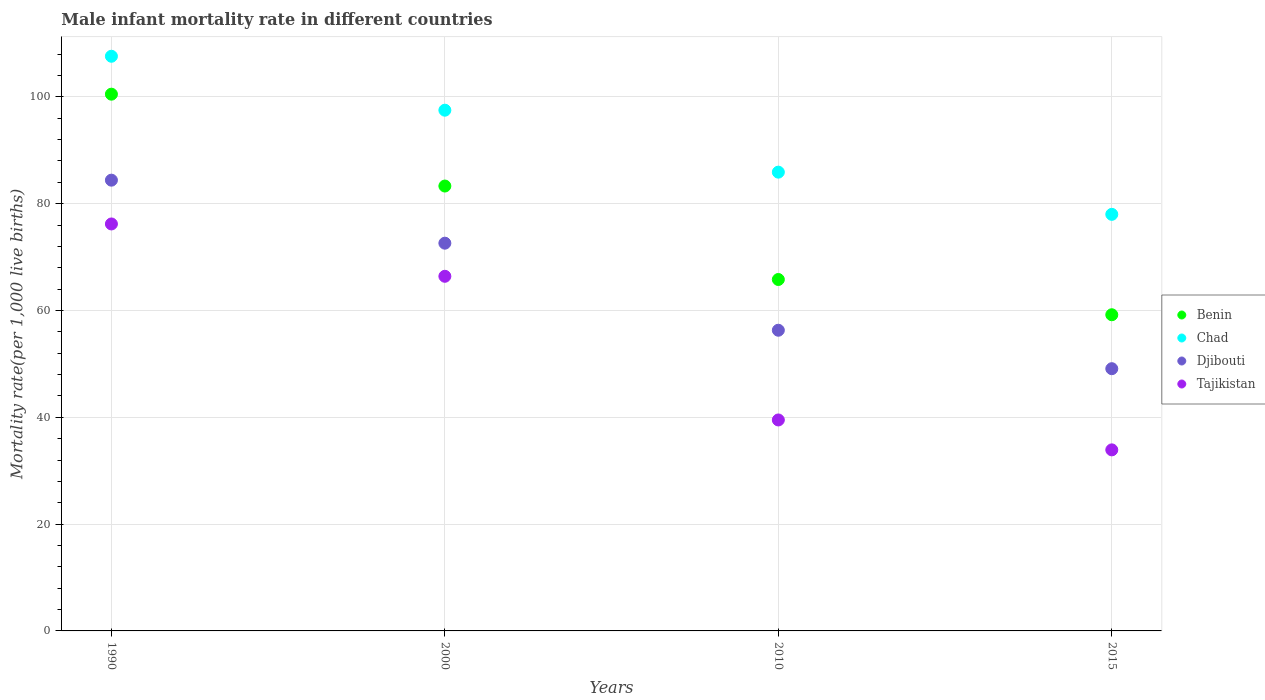Is the number of dotlines equal to the number of legend labels?
Your answer should be compact. Yes. What is the male infant mortality rate in Chad in 2000?
Your response must be concise. 97.5. Across all years, what is the maximum male infant mortality rate in Benin?
Offer a very short reply. 100.5. Across all years, what is the minimum male infant mortality rate in Benin?
Give a very brief answer. 59.2. In which year was the male infant mortality rate in Chad maximum?
Keep it short and to the point. 1990. In which year was the male infant mortality rate in Benin minimum?
Your answer should be very brief. 2015. What is the total male infant mortality rate in Tajikistan in the graph?
Give a very brief answer. 216. What is the difference between the male infant mortality rate in Djibouti in 1990 and that in 2015?
Provide a short and direct response. 35.3. What is the difference between the male infant mortality rate in Chad in 2000 and the male infant mortality rate in Tajikistan in 1990?
Your answer should be very brief. 21.3. What is the average male infant mortality rate in Djibouti per year?
Give a very brief answer. 65.6. In the year 2010, what is the difference between the male infant mortality rate in Chad and male infant mortality rate in Tajikistan?
Offer a terse response. 46.4. In how many years, is the male infant mortality rate in Chad greater than 40?
Give a very brief answer. 4. What is the ratio of the male infant mortality rate in Djibouti in 1990 to that in 2000?
Keep it short and to the point. 1.16. What is the difference between the highest and the second highest male infant mortality rate in Benin?
Provide a short and direct response. 17.2. What is the difference between the highest and the lowest male infant mortality rate in Chad?
Provide a succinct answer. 29.6. Is it the case that in every year, the sum of the male infant mortality rate in Chad and male infant mortality rate in Djibouti  is greater than the male infant mortality rate in Benin?
Your answer should be very brief. Yes. Does the male infant mortality rate in Chad monotonically increase over the years?
Your response must be concise. No. Is the male infant mortality rate in Tajikistan strictly greater than the male infant mortality rate in Benin over the years?
Provide a short and direct response. No. How many dotlines are there?
Offer a very short reply. 4. How many years are there in the graph?
Ensure brevity in your answer.  4. Are the values on the major ticks of Y-axis written in scientific E-notation?
Ensure brevity in your answer.  No. Does the graph contain any zero values?
Offer a very short reply. No. Does the graph contain grids?
Make the answer very short. Yes. How many legend labels are there?
Keep it short and to the point. 4. How are the legend labels stacked?
Give a very brief answer. Vertical. What is the title of the graph?
Offer a terse response. Male infant mortality rate in different countries. What is the label or title of the X-axis?
Provide a short and direct response. Years. What is the label or title of the Y-axis?
Your answer should be very brief. Mortality rate(per 1,0 live births). What is the Mortality rate(per 1,000 live births) of Benin in 1990?
Make the answer very short. 100.5. What is the Mortality rate(per 1,000 live births) of Chad in 1990?
Offer a terse response. 107.6. What is the Mortality rate(per 1,000 live births) of Djibouti in 1990?
Your answer should be very brief. 84.4. What is the Mortality rate(per 1,000 live births) of Tajikistan in 1990?
Offer a terse response. 76.2. What is the Mortality rate(per 1,000 live births) in Benin in 2000?
Ensure brevity in your answer.  83.3. What is the Mortality rate(per 1,000 live births) in Chad in 2000?
Offer a very short reply. 97.5. What is the Mortality rate(per 1,000 live births) of Djibouti in 2000?
Make the answer very short. 72.6. What is the Mortality rate(per 1,000 live births) in Tajikistan in 2000?
Offer a very short reply. 66.4. What is the Mortality rate(per 1,000 live births) in Benin in 2010?
Make the answer very short. 65.8. What is the Mortality rate(per 1,000 live births) of Chad in 2010?
Offer a terse response. 85.9. What is the Mortality rate(per 1,000 live births) in Djibouti in 2010?
Your answer should be very brief. 56.3. What is the Mortality rate(per 1,000 live births) in Tajikistan in 2010?
Ensure brevity in your answer.  39.5. What is the Mortality rate(per 1,000 live births) of Benin in 2015?
Offer a very short reply. 59.2. What is the Mortality rate(per 1,000 live births) of Chad in 2015?
Offer a very short reply. 78. What is the Mortality rate(per 1,000 live births) in Djibouti in 2015?
Your answer should be very brief. 49.1. What is the Mortality rate(per 1,000 live births) of Tajikistan in 2015?
Keep it short and to the point. 33.9. Across all years, what is the maximum Mortality rate(per 1,000 live births) of Benin?
Offer a terse response. 100.5. Across all years, what is the maximum Mortality rate(per 1,000 live births) in Chad?
Ensure brevity in your answer.  107.6. Across all years, what is the maximum Mortality rate(per 1,000 live births) of Djibouti?
Make the answer very short. 84.4. Across all years, what is the maximum Mortality rate(per 1,000 live births) of Tajikistan?
Keep it short and to the point. 76.2. Across all years, what is the minimum Mortality rate(per 1,000 live births) in Benin?
Provide a succinct answer. 59.2. Across all years, what is the minimum Mortality rate(per 1,000 live births) of Djibouti?
Offer a very short reply. 49.1. Across all years, what is the minimum Mortality rate(per 1,000 live births) of Tajikistan?
Your answer should be compact. 33.9. What is the total Mortality rate(per 1,000 live births) in Benin in the graph?
Your response must be concise. 308.8. What is the total Mortality rate(per 1,000 live births) of Chad in the graph?
Provide a short and direct response. 369. What is the total Mortality rate(per 1,000 live births) of Djibouti in the graph?
Your answer should be very brief. 262.4. What is the total Mortality rate(per 1,000 live births) in Tajikistan in the graph?
Make the answer very short. 216. What is the difference between the Mortality rate(per 1,000 live births) of Benin in 1990 and that in 2000?
Provide a short and direct response. 17.2. What is the difference between the Mortality rate(per 1,000 live births) of Djibouti in 1990 and that in 2000?
Your answer should be compact. 11.8. What is the difference between the Mortality rate(per 1,000 live births) in Benin in 1990 and that in 2010?
Make the answer very short. 34.7. What is the difference between the Mortality rate(per 1,000 live births) in Chad in 1990 and that in 2010?
Your response must be concise. 21.7. What is the difference between the Mortality rate(per 1,000 live births) of Djibouti in 1990 and that in 2010?
Give a very brief answer. 28.1. What is the difference between the Mortality rate(per 1,000 live births) of Tajikistan in 1990 and that in 2010?
Your response must be concise. 36.7. What is the difference between the Mortality rate(per 1,000 live births) of Benin in 1990 and that in 2015?
Give a very brief answer. 41.3. What is the difference between the Mortality rate(per 1,000 live births) in Chad in 1990 and that in 2015?
Your response must be concise. 29.6. What is the difference between the Mortality rate(per 1,000 live births) of Djibouti in 1990 and that in 2015?
Keep it short and to the point. 35.3. What is the difference between the Mortality rate(per 1,000 live births) in Tajikistan in 1990 and that in 2015?
Make the answer very short. 42.3. What is the difference between the Mortality rate(per 1,000 live births) of Benin in 2000 and that in 2010?
Your answer should be very brief. 17.5. What is the difference between the Mortality rate(per 1,000 live births) in Chad in 2000 and that in 2010?
Your answer should be compact. 11.6. What is the difference between the Mortality rate(per 1,000 live births) of Tajikistan in 2000 and that in 2010?
Make the answer very short. 26.9. What is the difference between the Mortality rate(per 1,000 live births) in Benin in 2000 and that in 2015?
Offer a terse response. 24.1. What is the difference between the Mortality rate(per 1,000 live births) in Chad in 2000 and that in 2015?
Keep it short and to the point. 19.5. What is the difference between the Mortality rate(per 1,000 live births) in Tajikistan in 2000 and that in 2015?
Offer a very short reply. 32.5. What is the difference between the Mortality rate(per 1,000 live births) of Djibouti in 2010 and that in 2015?
Provide a short and direct response. 7.2. What is the difference between the Mortality rate(per 1,000 live births) of Tajikistan in 2010 and that in 2015?
Your response must be concise. 5.6. What is the difference between the Mortality rate(per 1,000 live births) in Benin in 1990 and the Mortality rate(per 1,000 live births) in Djibouti in 2000?
Provide a short and direct response. 27.9. What is the difference between the Mortality rate(per 1,000 live births) in Benin in 1990 and the Mortality rate(per 1,000 live births) in Tajikistan in 2000?
Offer a terse response. 34.1. What is the difference between the Mortality rate(per 1,000 live births) of Chad in 1990 and the Mortality rate(per 1,000 live births) of Djibouti in 2000?
Ensure brevity in your answer.  35. What is the difference between the Mortality rate(per 1,000 live births) in Chad in 1990 and the Mortality rate(per 1,000 live births) in Tajikistan in 2000?
Keep it short and to the point. 41.2. What is the difference between the Mortality rate(per 1,000 live births) of Benin in 1990 and the Mortality rate(per 1,000 live births) of Djibouti in 2010?
Ensure brevity in your answer.  44.2. What is the difference between the Mortality rate(per 1,000 live births) of Chad in 1990 and the Mortality rate(per 1,000 live births) of Djibouti in 2010?
Offer a terse response. 51.3. What is the difference between the Mortality rate(per 1,000 live births) in Chad in 1990 and the Mortality rate(per 1,000 live births) in Tajikistan in 2010?
Offer a terse response. 68.1. What is the difference between the Mortality rate(per 1,000 live births) in Djibouti in 1990 and the Mortality rate(per 1,000 live births) in Tajikistan in 2010?
Make the answer very short. 44.9. What is the difference between the Mortality rate(per 1,000 live births) in Benin in 1990 and the Mortality rate(per 1,000 live births) in Chad in 2015?
Your answer should be very brief. 22.5. What is the difference between the Mortality rate(per 1,000 live births) of Benin in 1990 and the Mortality rate(per 1,000 live births) of Djibouti in 2015?
Your answer should be very brief. 51.4. What is the difference between the Mortality rate(per 1,000 live births) in Benin in 1990 and the Mortality rate(per 1,000 live births) in Tajikistan in 2015?
Your answer should be compact. 66.6. What is the difference between the Mortality rate(per 1,000 live births) of Chad in 1990 and the Mortality rate(per 1,000 live births) of Djibouti in 2015?
Keep it short and to the point. 58.5. What is the difference between the Mortality rate(per 1,000 live births) in Chad in 1990 and the Mortality rate(per 1,000 live births) in Tajikistan in 2015?
Give a very brief answer. 73.7. What is the difference between the Mortality rate(per 1,000 live births) in Djibouti in 1990 and the Mortality rate(per 1,000 live births) in Tajikistan in 2015?
Your answer should be compact. 50.5. What is the difference between the Mortality rate(per 1,000 live births) in Benin in 2000 and the Mortality rate(per 1,000 live births) in Chad in 2010?
Offer a terse response. -2.6. What is the difference between the Mortality rate(per 1,000 live births) of Benin in 2000 and the Mortality rate(per 1,000 live births) of Djibouti in 2010?
Your answer should be compact. 27. What is the difference between the Mortality rate(per 1,000 live births) in Benin in 2000 and the Mortality rate(per 1,000 live births) in Tajikistan in 2010?
Your response must be concise. 43.8. What is the difference between the Mortality rate(per 1,000 live births) of Chad in 2000 and the Mortality rate(per 1,000 live births) of Djibouti in 2010?
Provide a short and direct response. 41.2. What is the difference between the Mortality rate(per 1,000 live births) of Chad in 2000 and the Mortality rate(per 1,000 live births) of Tajikistan in 2010?
Your answer should be compact. 58. What is the difference between the Mortality rate(per 1,000 live births) in Djibouti in 2000 and the Mortality rate(per 1,000 live births) in Tajikistan in 2010?
Make the answer very short. 33.1. What is the difference between the Mortality rate(per 1,000 live births) of Benin in 2000 and the Mortality rate(per 1,000 live births) of Chad in 2015?
Ensure brevity in your answer.  5.3. What is the difference between the Mortality rate(per 1,000 live births) of Benin in 2000 and the Mortality rate(per 1,000 live births) of Djibouti in 2015?
Provide a succinct answer. 34.2. What is the difference between the Mortality rate(per 1,000 live births) in Benin in 2000 and the Mortality rate(per 1,000 live births) in Tajikistan in 2015?
Your answer should be compact. 49.4. What is the difference between the Mortality rate(per 1,000 live births) of Chad in 2000 and the Mortality rate(per 1,000 live births) of Djibouti in 2015?
Provide a short and direct response. 48.4. What is the difference between the Mortality rate(per 1,000 live births) of Chad in 2000 and the Mortality rate(per 1,000 live births) of Tajikistan in 2015?
Provide a short and direct response. 63.6. What is the difference between the Mortality rate(per 1,000 live births) of Djibouti in 2000 and the Mortality rate(per 1,000 live births) of Tajikistan in 2015?
Provide a succinct answer. 38.7. What is the difference between the Mortality rate(per 1,000 live births) of Benin in 2010 and the Mortality rate(per 1,000 live births) of Djibouti in 2015?
Give a very brief answer. 16.7. What is the difference between the Mortality rate(per 1,000 live births) of Benin in 2010 and the Mortality rate(per 1,000 live births) of Tajikistan in 2015?
Provide a succinct answer. 31.9. What is the difference between the Mortality rate(per 1,000 live births) in Chad in 2010 and the Mortality rate(per 1,000 live births) in Djibouti in 2015?
Provide a succinct answer. 36.8. What is the difference between the Mortality rate(per 1,000 live births) in Djibouti in 2010 and the Mortality rate(per 1,000 live births) in Tajikistan in 2015?
Provide a succinct answer. 22.4. What is the average Mortality rate(per 1,000 live births) of Benin per year?
Your answer should be very brief. 77.2. What is the average Mortality rate(per 1,000 live births) in Chad per year?
Your answer should be very brief. 92.25. What is the average Mortality rate(per 1,000 live births) of Djibouti per year?
Offer a very short reply. 65.6. What is the average Mortality rate(per 1,000 live births) in Tajikistan per year?
Offer a very short reply. 54. In the year 1990, what is the difference between the Mortality rate(per 1,000 live births) of Benin and Mortality rate(per 1,000 live births) of Tajikistan?
Ensure brevity in your answer.  24.3. In the year 1990, what is the difference between the Mortality rate(per 1,000 live births) in Chad and Mortality rate(per 1,000 live births) in Djibouti?
Offer a terse response. 23.2. In the year 1990, what is the difference between the Mortality rate(per 1,000 live births) in Chad and Mortality rate(per 1,000 live births) in Tajikistan?
Give a very brief answer. 31.4. In the year 2000, what is the difference between the Mortality rate(per 1,000 live births) in Benin and Mortality rate(per 1,000 live births) in Djibouti?
Ensure brevity in your answer.  10.7. In the year 2000, what is the difference between the Mortality rate(per 1,000 live births) in Chad and Mortality rate(per 1,000 live births) in Djibouti?
Keep it short and to the point. 24.9. In the year 2000, what is the difference between the Mortality rate(per 1,000 live births) of Chad and Mortality rate(per 1,000 live births) of Tajikistan?
Your answer should be very brief. 31.1. In the year 2000, what is the difference between the Mortality rate(per 1,000 live births) in Djibouti and Mortality rate(per 1,000 live births) in Tajikistan?
Your answer should be very brief. 6.2. In the year 2010, what is the difference between the Mortality rate(per 1,000 live births) in Benin and Mortality rate(per 1,000 live births) in Chad?
Ensure brevity in your answer.  -20.1. In the year 2010, what is the difference between the Mortality rate(per 1,000 live births) in Benin and Mortality rate(per 1,000 live births) in Tajikistan?
Offer a very short reply. 26.3. In the year 2010, what is the difference between the Mortality rate(per 1,000 live births) in Chad and Mortality rate(per 1,000 live births) in Djibouti?
Your answer should be very brief. 29.6. In the year 2010, what is the difference between the Mortality rate(per 1,000 live births) in Chad and Mortality rate(per 1,000 live births) in Tajikistan?
Make the answer very short. 46.4. In the year 2010, what is the difference between the Mortality rate(per 1,000 live births) of Djibouti and Mortality rate(per 1,000 live births) of Tajikistan?
Provide a succinct answer. 16.8. In the year 2015, what is the difference between the Mortality rate(per 1,000 live births) in Benin and Mortality rate(per 1,000 live births) in Chad?
Your response must be concise. -18.8. In the year 2015, what is the difference between the Mortality rate(per 1,000 live births) of Benin and Mortality rate(per 1,000 live births) of Tajikistan?
Offer a terse response. 25.3. In the year 2015, what is the difference between the Mortality rate(per 1,000 live births) of Chad and Mortality rate(per 1,000 live births) of Djibouti?
Provide a succinct answer. 28.9. In the year 2015, what is the difference between the Mortality rate(per 1,000 live births) of Chad and Mortality rate(per 1,000 live births) of Tajikistan?
Offer a very short reply. 44.1. What is the ratio of the Mortality rate(per 1,000 live births) in Benin in 1990 to that in 2000?
Provide a short and direct response. 1.21. What is the ratio of the Mortality rate(per 1,000 live births) of Chad in 1990 to that in 2000?
Make the answer very short. 1.1. What is the ratio of the Mortality rate(per 1,000 live births) in Djibouti in 1990 to that in 2000?
Provide a short and direct response. 1.16. What is the ratio of the Mortality rate(per 1,000 live births) in Tajikistan in 1990 to that in 2000?
Make the answer very short. 1.15. What is the ratio of the Mortality rate(per 1,000 live births) in Benin in 1990 to that in 2010?
Your response must be concise. 1.53. What is the ratio of the Mortality rate(per 1,000 live births) in Chad in 1990 to that in 2010?
Make the answer very short. 1.25. What is the ratio of the Mortality rate(per 1,000 live births) of Djibouti in 1990 to that in 2010?
Your answer should be very brief. 1.5. What is the ratio of the Mortality rate(per 1,000 live births) in Tajikistan in 1990 to that in 2010?
Offer a terse response. 1.93. What is the ratio of the Mortality rate(per 1,000 live births) of Benin in 1990 to that in 2015?
Ensure brevity in your answer.  1.7. What is the ratio of the Mortality rate(per 1,000 live births) in Chad in 1990 to that in 2015?
Provide a short and direct response. 1.38. What is the ratio of the Mortality rate(per 1,000 live births) in Djibouti in 1990 to that in 2015?
Provide a short and direct response. 1.72. What is the ratio of the Mortality rate(per 1,000 live births) of Tajikistan in 1990 to that in 2015?
Provide a short and direct response. 2.25. What is the ratio of the Mortality rate(per 1,000 live births) of Benin in 2000 to that in 2010?
Make the answer very short. 1.27. What is the ratio of the Mortality rate(per 1,000 live births) in Chad in 2000 to that in 2010?
Keep it short and to the point. 1.14. What is the ratio of the Mortality rate(per 1,000 live births) in Djibouti in 2000 to that in 2010?
Your answer should be very brief. 1.29. What is the ratio of the Mortality rate(per 1,000 live births) of Tajikistan in 2000 to that in 2010?
Offer a terse response. 1.68. What is the ratio of the Mortality rate(per 1,000 live births) of Benin in 2000 to that in 2015?
Provide a short and direct response. 1.41. What is the ratio of the Mortality rate(per 1,000 live births) in Chad in 2000 to that in 2015?
Keep it short and to the point. 1.25. What is the ratio of the Mortality rate(per 1,000 live births) of Djibouti in 2000 to that in 2015?
Your answer should be very brief. 1.48. What is the ratio of the Mortality rate(per 1,000 live births) in Tajikistan in 2000 to that in 2015?
Your response must be concise. 1.96. What is the ratio of the Mortality rate(per 1,000 live births) of Benin in 2010 to that in 2015?
Make the answer very short. 1.11. What is the ratio of the Mortality rate(per 1,000 live births) in Chad in 2010 to that in 2015?
Provide a short and direct response. 1.1. What is the ratio of the Mortality rate(per 1,000 live births) of Djibouti in 2010 to that in 2015?
Your answer should be compact. 1.15. What is the ratio of the Mortality rate(per 1,000 live births) of Tajikistan in 2010 to that in 2015?
Make the answer very short. 1.17. What is the difference between the highest and the second highest Mortality rate(per 1,000 live births) in Benin?
Provide a succinct answer. 17.2. What is the difference between the highest and the second highest Mortality rate(per 1,000 live births) of Djibouti?
Provide a short and direct response. 11.8. What is the difference between the highest and the lowest Mortality rate(per 1,000 live births) of Benin?
Provide a succinct answer. 41.3. What is the difference between the highest and the lowest Mortality rate(per 1,000 live births) of Chad?
Keep it short and to the point. 29.6. What is the difference between the highest and the lowest Mortality rate(per 1,000 live births) of Djibouti?
Offer a very short reply. 35.3. What is the difference between the highest and the lowest Mortality rate(per 1,000 live births) of Tajikistan?
Give a very brief answer. 42.3. 